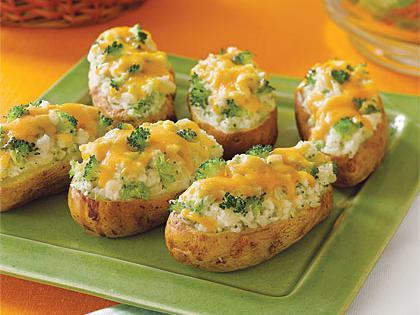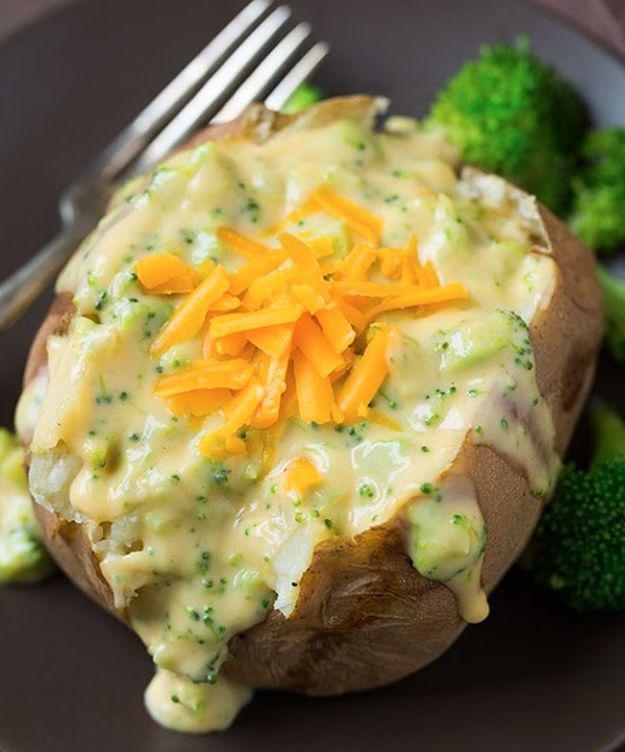The first image is the image on the left, the second image is the image on the right. Analyze the images presented: Is the assertion "Each image contains at least three baked stuffed potato." valid? Answer yes or no. No. The first image is the image on the left, the second image is the image on the right. Given the left and right images, does the statement "There is one piece of food on the dish on the right." hold true? Answer yes or no. Yes. 